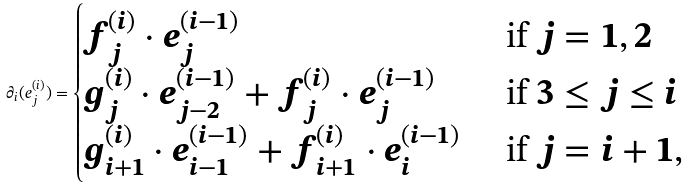<formula> <loc_0><loc_0><loc_500><loc_500>\partial _ { i } ( e _ { j } ^ { ( i ) } ) = \begin{cases} f _ { j } ^ { ( i ) } \cdot e _ { j } ^ { ( i - 1 ) } & \text { if $j=1,2$} \\ g _ { j } ^ { ( i ) } \cdot e _ { j - 2 } ^ { ( i - 1 ) } + f _ { j } ^ { ( i ) } \cdot e _ { j } ^ { ( i - 1 ) } & \text { if $3\leq j\leq i$} \\ g _ { i + 1 } ^ { ( i ) } \cdot e _ { i - 1 } ^ { ( i - 1 ) } + f _ { i + 1 } ^ { ( i ) } \cdot e _ { i } ^ { ( i - 1 ) } & \text { if $j=i+1$,} \end{cases}</formula> 